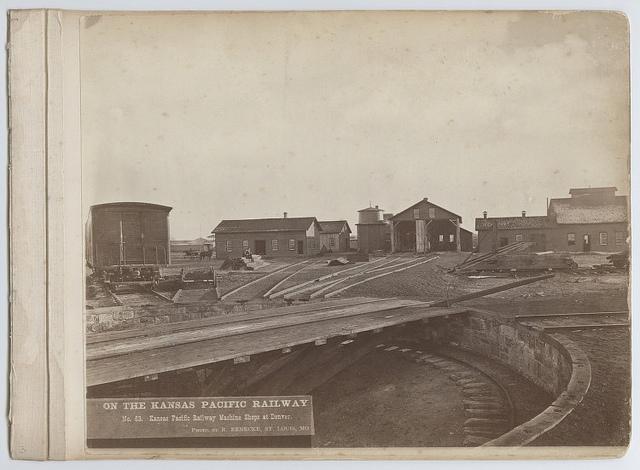Does this remind you of 1960's California?
Short answer required. No. What is cast?
Keep it brief. Shadows. Is the building brick?
Give a very brief answer. Yes. Are there any cars or trains in this photo?
Write a very short answer. No. Is this photograph more than 10 years old?
Quick response, please. Yes. Is it a black and white picture?
Short answer required. Yes. 